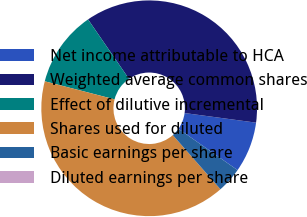Convert chart to OTSL. <chart><loc_0><loc_0><loc_500><loc_500><pie_chart><fcel>Net income attributable to HCA<fcel>Weighted average common shares<fcel>Effect of dilutive incremental<fcel>Shares used for diluted<fcel>Basic earnings per share<fcel>Diluted earnings per share<nl><fcel>7.59%<fcel>36.72%<fcel>11.39%<fcel>40.51%<fcel>3.8%<fcel>0.0%<nl></chart> 